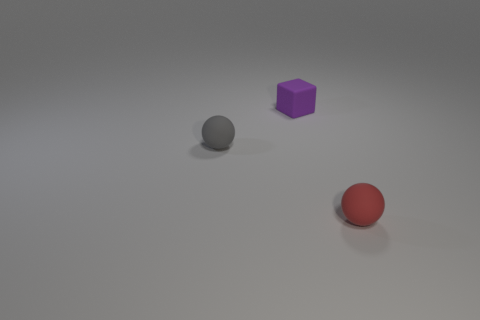Add 2 tiny red rubber objects. How many objects exist? 5 Subtract all blocks. How many objects are left? 2 Subtract all tiny red spheres. Subtract all large yellow cubes. How many objects are left? 2 Add 2 tiny blocks. How many tiny blocks are left? 3 Add 3 blue balls. How many blue balls exist? 3 Subtract 0 cyan cylinders. How many objects are left? 3 